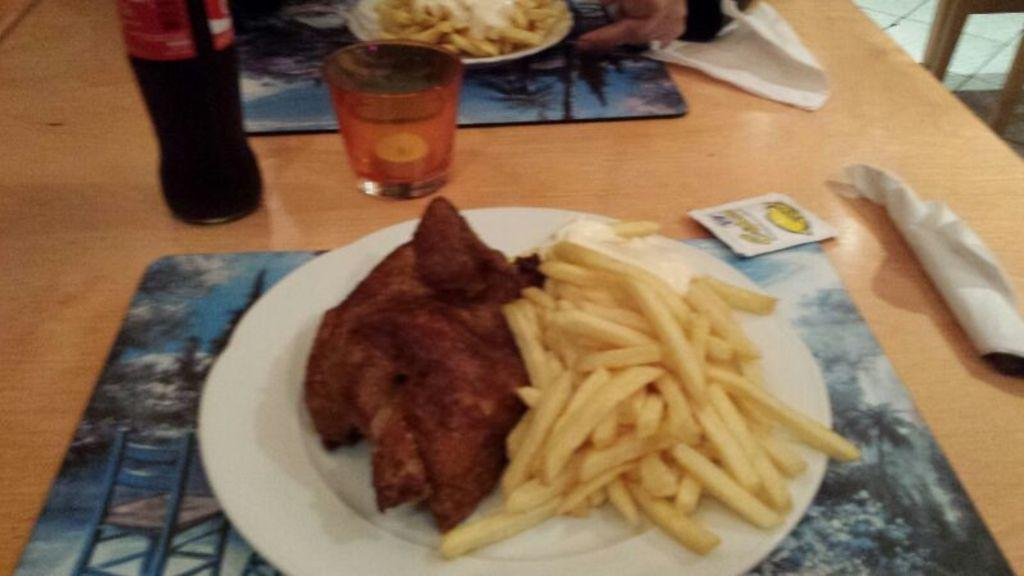What type of food is on the plate in the image? There is a plate with french fries and meat in the image. What is the plate placed on? The plate is on a wooden table. What type of beverage is visible in the image? There is a soft drink in the image. What is used for holding the soft drink? There is a glass in the image. What can be used for cleaning or wiping in the image? There are tissues in the image. Are there any other plates with food in the image? Yes, there is another plate with french fries in the image. What type of cast can be seen on the person's arm in the image? There is no person or cast present in the image; it only features a plate with food, a soft drink, a glass, tissues, and a wooden table. 